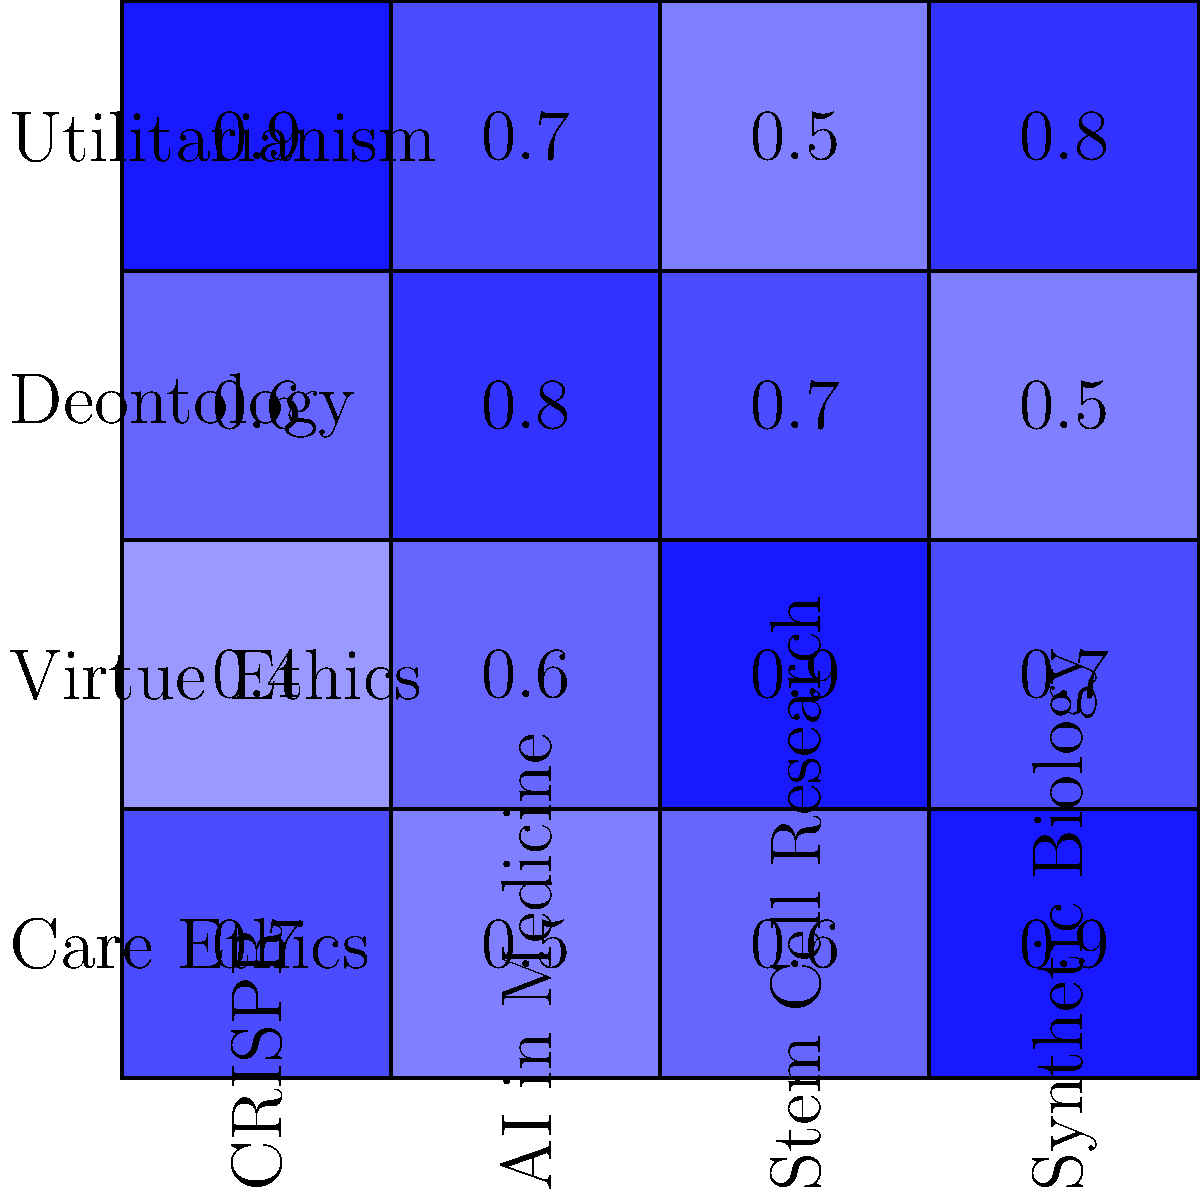Based on the ethical framework comparison matrix for emerging biotechnologies, which ethical framework appears to be most supportive of CRISPR technology, and what implications might this have for its development and regulation? To answer this question, we need to analyze the matrix systematically:

1. Identify the column for CRISPR technology (first column).
2. Compare the values in this column for each ethical framework:
   - Utilitarianism: 0.9
   - Deontology: 0.6
   - Virtue Ethics: 0.4
   - Care Ethics: 0.7

3. The highest value in the CRISPR column is 0.9, corresponding to Utilitarianism.

4. Implications of Utilitarianism being most supportive:
   a) Focus on outcomes: Utilitarianism emphasizes the greatest good for the greatest number, suggesting CRISPR's potential benefits are viewed as outweighing potential risks.
   b) Emphasis on quantifiable benefits: This could lead to prioritizing measurable outcomes like disease prevention over less tangible concerns.
   c) Potential for rapid development: With strong utilitarian support, CRISPR research might face fewer ethical barriers.
   d) Regulatory challenges: Balancing utilitarian support with other ethical considerations may require nuanced regulatory approaches.
   e) Need for comprehensive cost-benefit analysis: Utilitarian framework would demand thorough evaluation of both short-term and long-term consequences.

5. It's important to note that while Utilitarianism is most supportive, other frameworks also show significant support (e.g., Care Ethics at 0.7), indicating a need for a balanced approach in development and regulation.
Answer: Utilitarianism; implies focus on outcomes, potential for rapid development, and need for comprehensive cost-benefit analysis in regulation. 